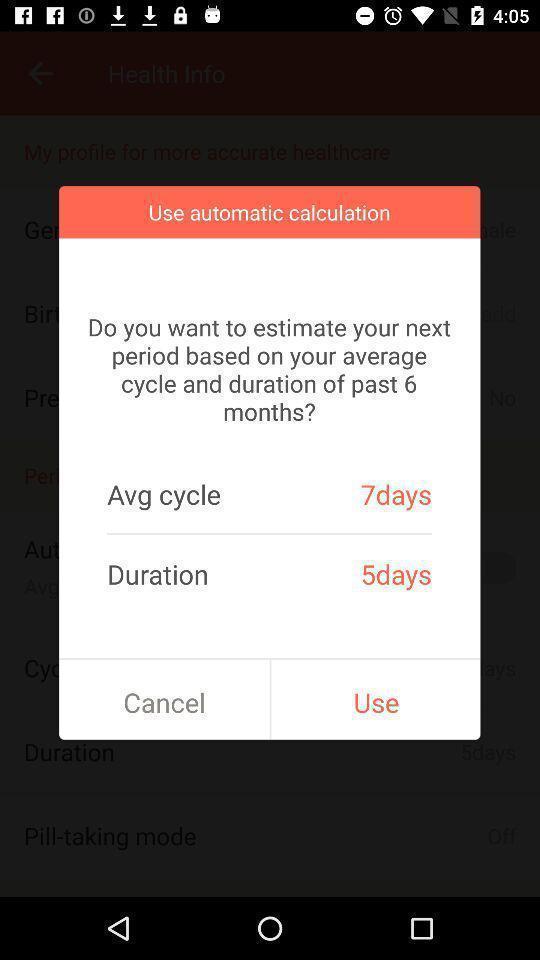Describe the content in this image. Pop-up showing to use automatic calculation. 